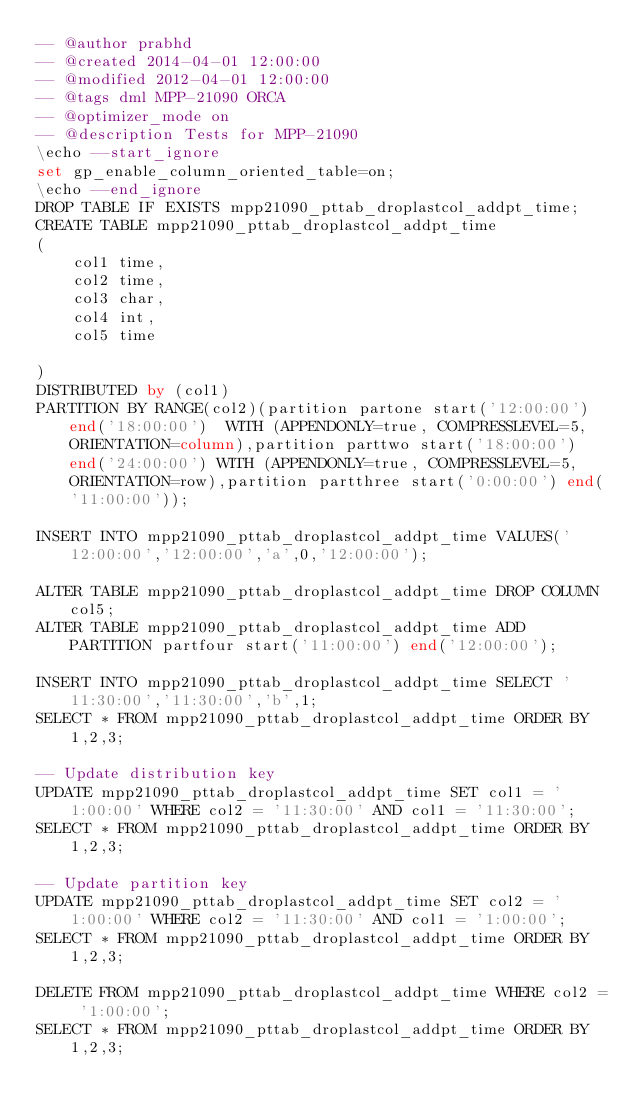<code> <loc_0><loc_0><loc_500><loc_500><_SQL_>-- @author prabhd 
-- @created 2014-04-01 12:00:00
-- @modified 2012-04-01 12:00:00
-- @tags dml MPP-21090 ORCA
-- @optimizer_mode on	
-- @description Tests for MPP-21090
\echo --start_ignore
set gp_enable_column_oriented_table=on;
\echo --end_ignore
DROP TABLE IF EXISTS mpp21090_pttab_droplastcol_addpt_time;
CREATE TABLE mpp21090_pttab_droplastcol_addpt_time
(
    col1 time,
    col2 time,
    col3 char,
    col4 int,
    col5 time
    
) 
DISTRIBUTED by (col1)
PARTITION BY RANGE(col2)(partition partone start('12:00:00') end('18:00:00')  WITH (APPENDONLY=true, COMPRESSLEVEL=5, ORIENTATION=column),partition parttwo start('18:00:00') end('24:00:00') WITH (APPENDONLY=true, COMPRESSLEVEL=5, ORIENTATION=row),partition partthree start('0:00:00') end('11:00:00'));

INSERT INTO mpp21090_pttab_droplastcol_addpt_time VALUES('12:00:00','12:00:00','a',0,'12:00:00');

ALTER TABLE mpp21090_pttab_droplastcol_addpt_time DROP COLUMN col5;
ALTER TABLE mpp21090_pttab_droplastcol_addpt_time ADD PARTITION partfour start('11:00:00') end('12:00:00');

INSERT INTO mpp21090_pttab_droplastcol_addpt_time SELECT '11:30:00','11:30:00','b',1;
SELECT * FROM mpp21090_pttab_droplastcol_addpt_time ORDER BY 1,2,3;

-- Update distribution key
UPDATE mpp21090_pttab_droplastcol_addpt_time SET col1 = '1:00:00' WHERE col2 = '11:30:00' AND col1 = '11:30:00';
SELECT * FROM mpp21090_pttab_droplastcol_addpt_time ORDER BY 1,2,3;

-- Update partition key
UPDATE mpp21090_pttab_droplastcol_addpt_time SET col2 = '1:00:00' WHERE col2 = '11:30:00' AND col1 = '1:00:00';
SELECT * FROM mpp21090_pttab_droplastcol_addpt_time ORDER BY 1,2,3;

DELETE FROM mpp21090_pttab_droplastcol_addpt_time WHERE col2 = '1:00:00';
SELECT * FROM mpp21090_pttab_droplastcol_addpt_time ORDER BY 1,2,3;

</code> 